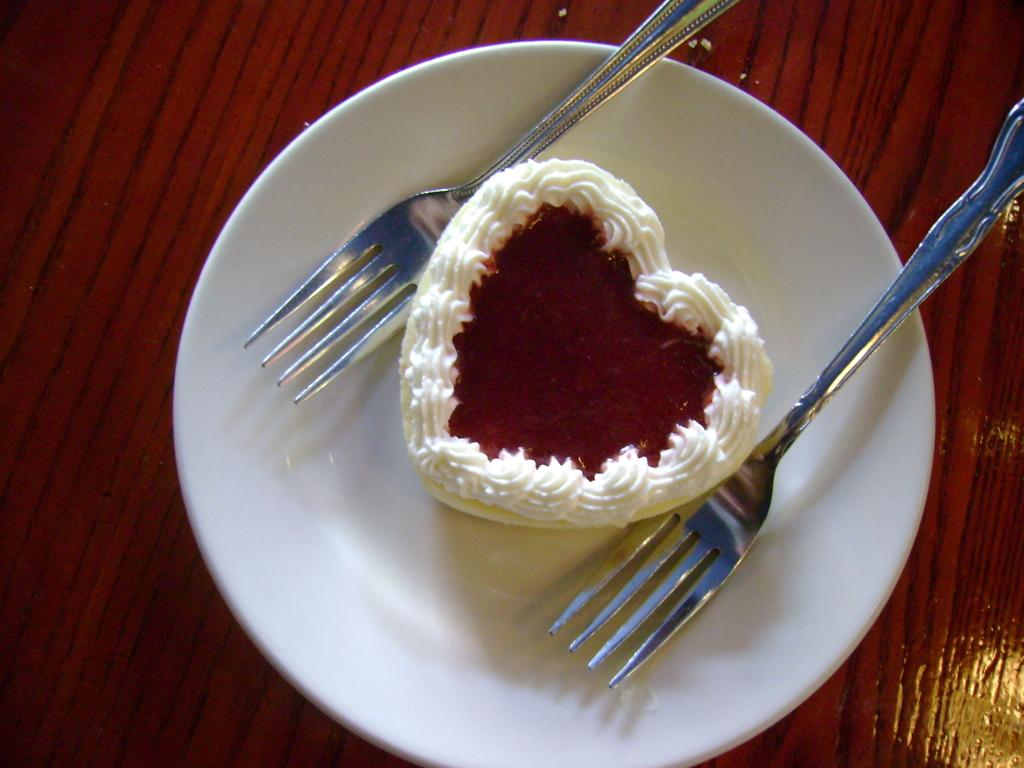What is present on the wooden platform in the image? There is a plate, forks, and a cake present on the wooden platform in the image. What might be used for eating the cake in the image? The forks in the image might be used for eating the cake. Can you describe the wooden platform in the image? The plate, forks, and cake are on a wooden platform in the image. What type of brick is used to construct the sidewalk in the image? There is no sidewalk or brick present in the image. What kind of shock can be seen affecting the cake in the image? There is no shock or any indication of a shock affecting the cake in the image. 